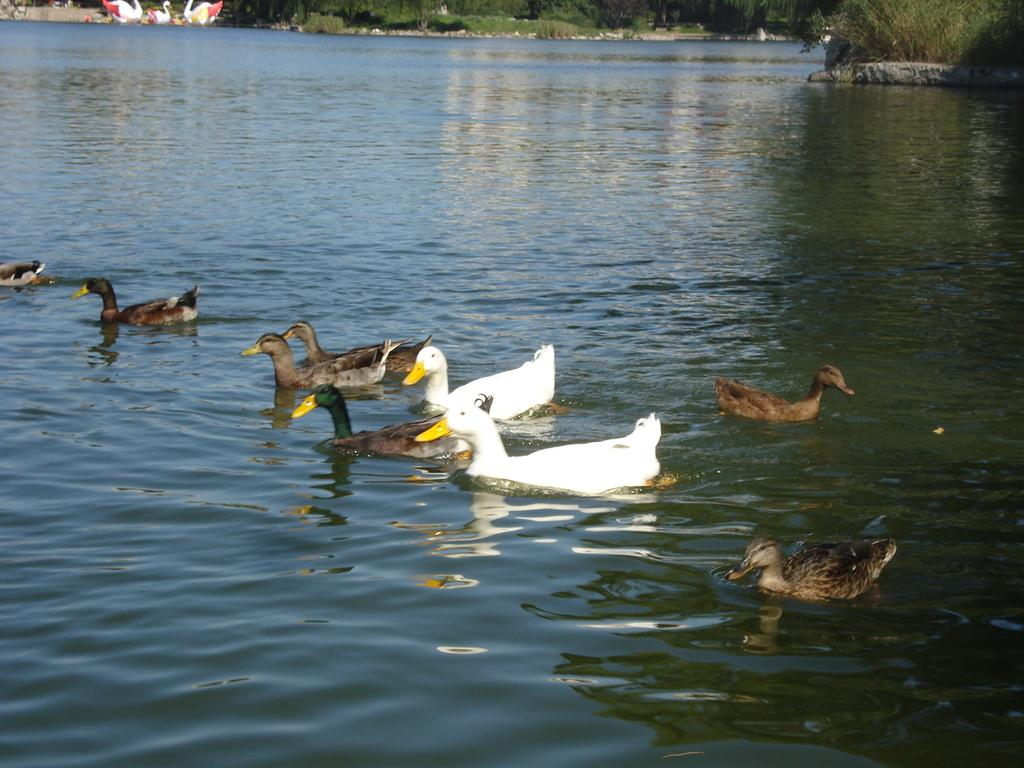What animals can be seen in the water in the image? There are ducks in the water in the image. What can be seen in the background of the image? There are trees and statues of ducks in the background of the image. What type of hat is the duck wearing in the image? There are no ducks wearing hats in the image; the ducks are in the water and the statues of ducks are stationary. 